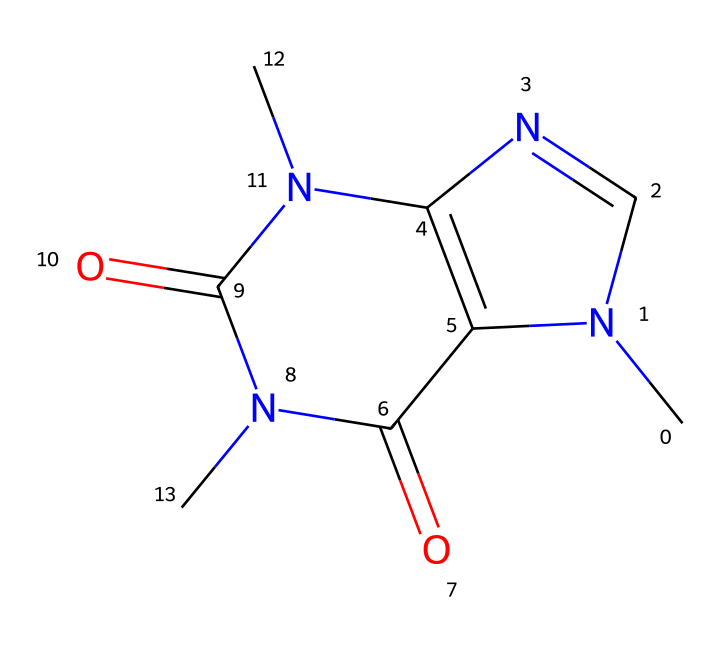What is the name of this chemical? The given SMILES representation corresponds to a common stimulant known as caffeine, which is a well-known chemical used in energy drinks.
Answer: caffeine How many nitrogen atoms are present in this structure? By analyzing the SMILES representation, there are three nitrogen atoms (N) indicated, which can be counted by locating each N in the structure.
Answer: three What is the number of carbon atoms in this chemical? Counting the carbon atoms (C) in the chemical structure based on the SMILES, there are eight carbon atoms present in total.
Answer: eight Does this chemical contain any oxygen atoms? In the provided chemical structure, there are two oxygen atoms (O) present, which can be identified in the SMILES representation as part of the carbonyl (C=O) functional groups.
Answer: yes What type of chemical is caffeine classified as? Caffeine is classified as an alkaloid due to the presence of nitrogen atoms and its psychoactive properties, typical of alkaloids.
Answer: alkaloid How many double bonds are present in the structure? By examining the structure in the SMILES, we can see there are two distinct double bonds (C=N and C=O), leading to a total of two double bonds.
Answer: two What is the simplest functional group evident in this structure? The presence of carbonyl groups (C=O) indicates that the simplest functional group observed here is the carbonyl functional group, characteristic of many organic compounds.
Answer: carbonyl group 